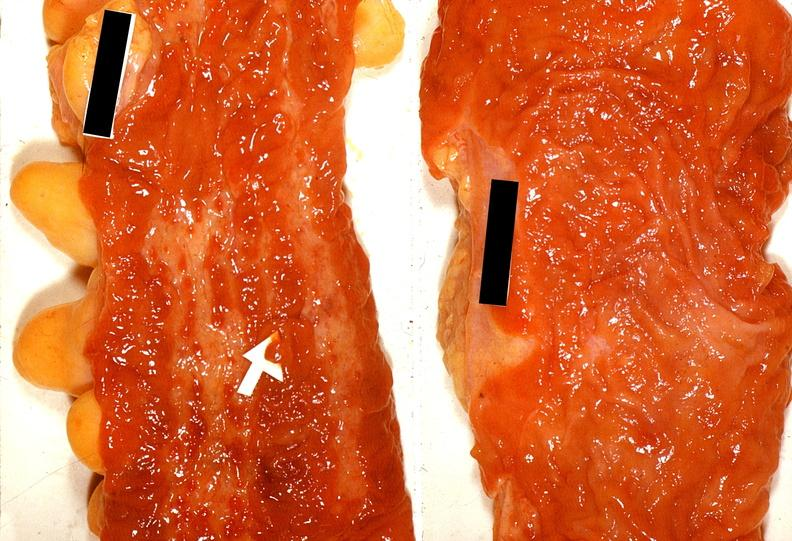does lymphoma show colon, ulcerative colitis?
Answer the question using a single word or phrase. No 